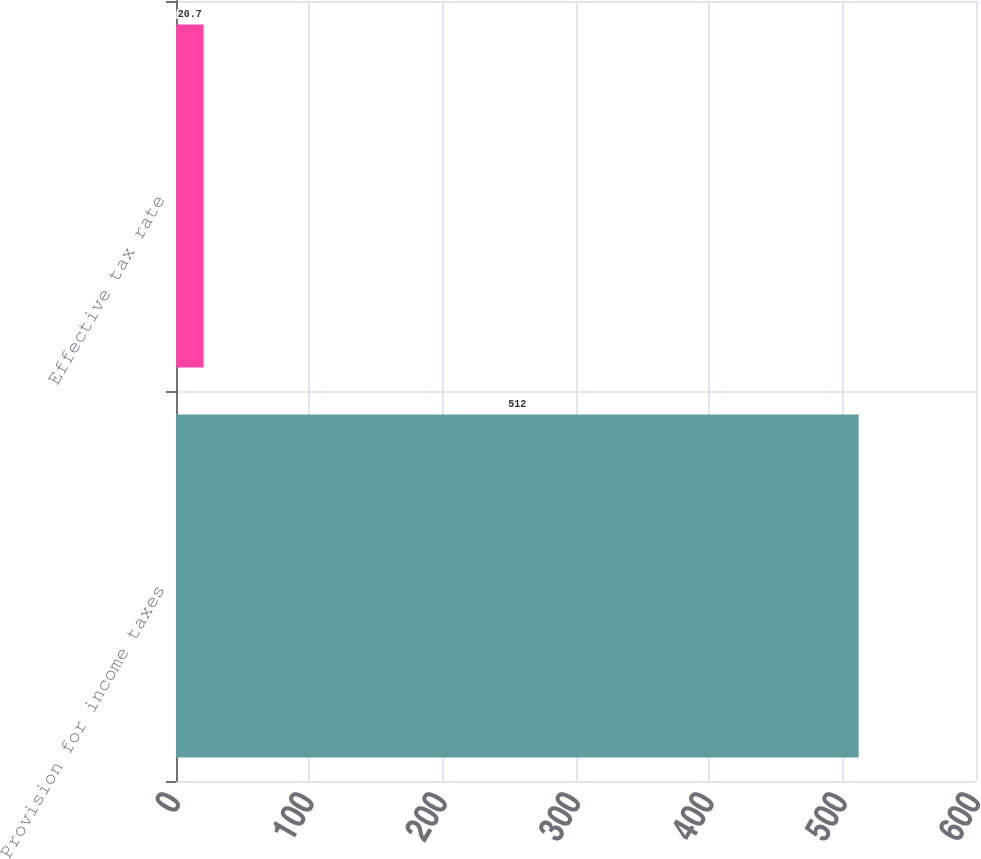<chart> <loc_0><loc_0><loc_500><loc_500><bar_chart><fcel>Provision for income taxes<fcel>Effective tax rate<nl><fcel>512<fcel>20.7<nl></chart> 